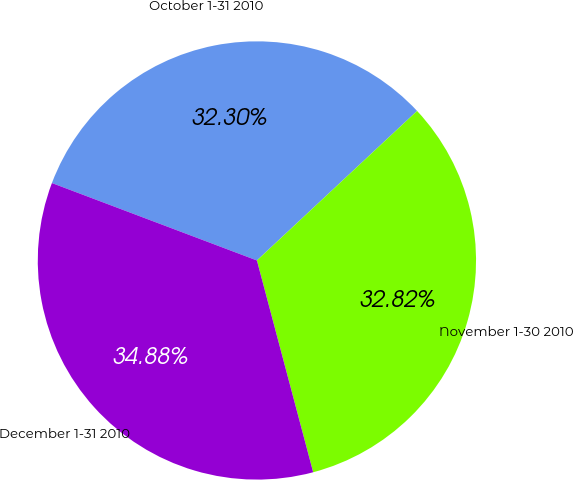Convert chart. <chart><loc_0><loc_0><loc_500><loc_500><pie_chart><fcel>October 1-31 2010<fcel>November 1-30 2010<fcel>December 1-31 2010<nl><fcel>32.3%<fcel>32.82%<fcel>34.88%<nl></chart> 